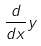<formula> <loc_0><loc_0><loc_500><loc_500>\frac { d } { d x } y</formula> 